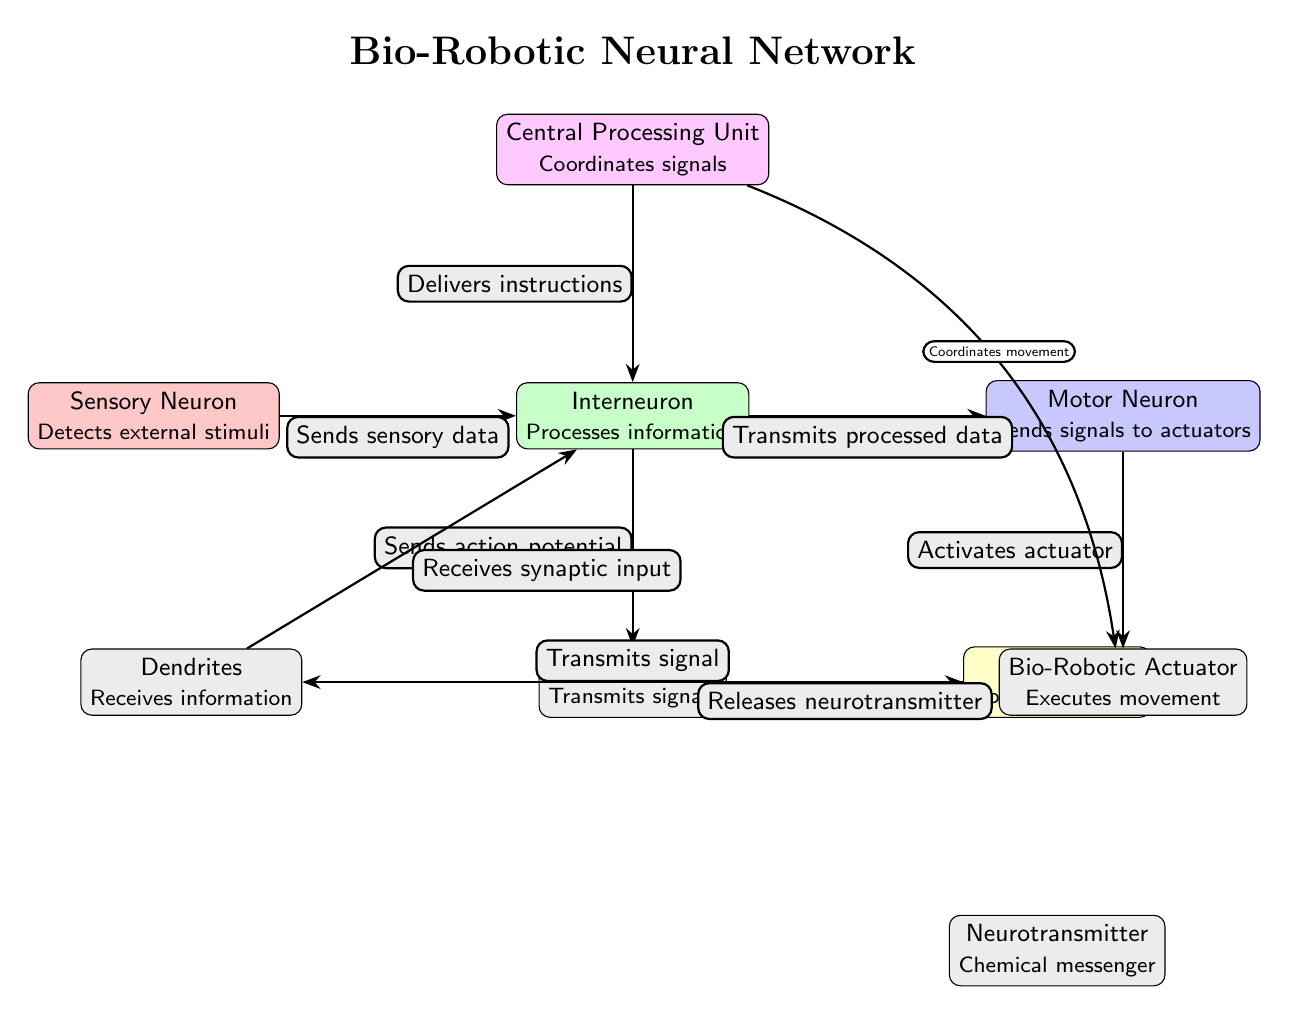What type of neuron is node 01? Node 01 is labeled as "Sensory Neuron," which is shown in the diagram. This is confirmed by the descriptive text which explains its function of detecting external stimuli.
Answer: Sensory Neuron How many nodes are in the diagram? By counting the distinct nodes represented, we find there are nine nodes in total: Sensory Neuron, Interneuron, Motor Neuron, Axon Terminal, Dendrites, Synapse, Neurotransmitter, Bio-Robotic Actuator, and Central Processing Unit.
Answer: 9 What does the inter neuron transmit? The inter neuron is indicated to transmit "processed data" to the motor neuron, as specified by the edge label connecting these two nodes in the diagram.
Answer: Processed data Which component activates the actuator? The Motor Neuron is responsible for activating the actuator, as indicated by the connection from the Motor Neuron to the Bio-Robotic Actuator labeled "Activates actuator."
Answer: Motor Neuron What role does the CPU play in the interaction map? The Central Processing Unit delivers instructions to the Interneuron and coordinates movement to the Bio-Robotic Actuator, as indicated by the connecting edges in the diagram.
Answer: Coordinates signals What is the relationship between the Axon Terminal and the Synapse? The Axon Terminal "Releases neurotransmitter" to the Synapse, highlighting the flow of signals depicted by the connecting edge in this interaction map.
Answer: Releases neurotransmitter What type of neuron is directly linked to the Bio-Robotic Actuator? The Motor Neuron is the only neuron directly linked to the Bio-Robotic Actuator, as shown by the edge labeled "Activates actuator" connecting these two nodes.
Answer: Motor Neuron How is information received by the interneuron? The interneuron receives information from Dendrites, which is described by the edge labeled "Receives synaptic input" that connects these two components in the interaction map.
Answer: Dendrites What does the Neurotransmitter represent in the diagram? The Neurotransmitter is identified as a "Chemical messenger," which is indicated in the diagram as a role involved in transmitting signals across the synapse.
Answer: Chemical messenger 